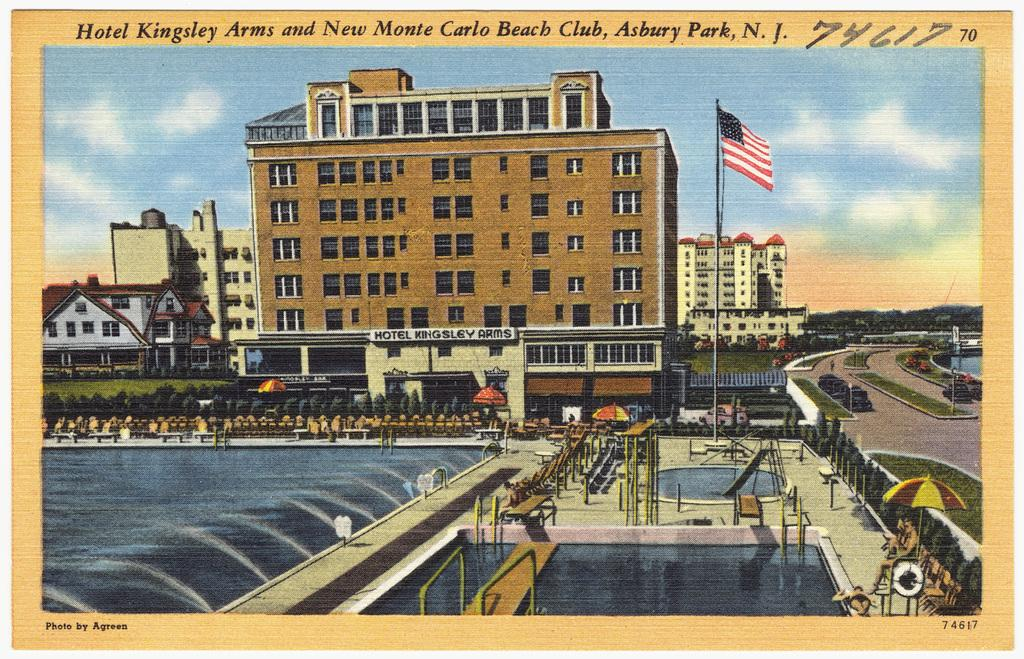What type of structures can be seen in the image? There are many buildings in the image. What is located in front of the buildings? There is a park in front of the buildings. What features can be found in the park? There is a swimming pool, a fountain, a pole with a flag, and trees in the park. What is beside the buildings? There is a road beside the buildings. How many divisions can be seen in the body of the person walking in the park? There is no person walking in the park, and therefore no body or divisions can be observed. What type of bead is used to decorate the flag on the pole in the park? There is no mention of beads or any specific decorations on the flag in the image. 